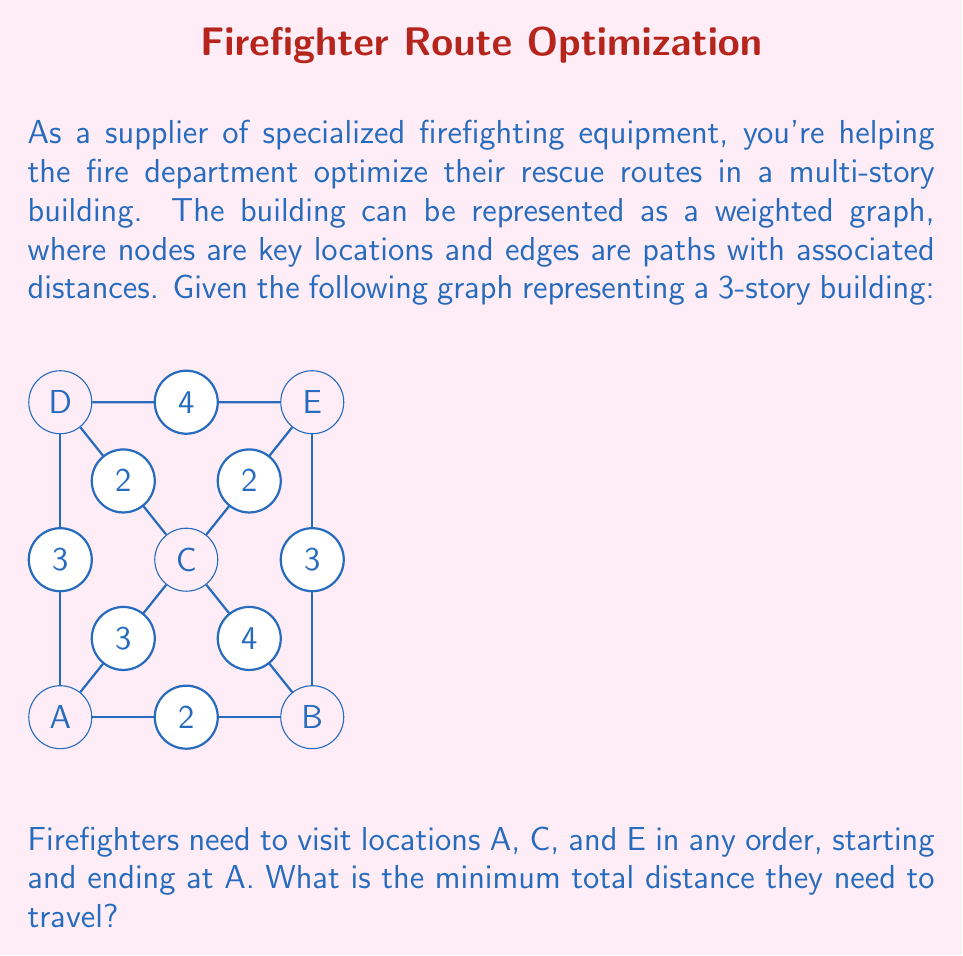Help me with this question. To solve this problem, we need to find the shortest path that starts at A, visits C and E in any order, and returns to A. This is a variation of the Traveling Salesman Problem.

Given the small number of nodes, we can solve this by considering all possible routes:

1. A → C → E → A
   Distance: 3 + 2 + 3 = 8

2. A → E → C → A
   Distance: 5 + 2 + 3 = 10

Let's calculate these distances step-by-step:

Route 1: A → C → E → A
- A to C: 3
- C to E: 2
- E to A: 3 (E → B → A)
Total: 3 + 2 + 3 = 8

Route 2: A → E → C → A
- A to E: 5 (A → B → E)
- E to C: 2
- C to A: 3
Total: 5 + 2 + 3 = 10

The shorter of these two routes is Route 1, with a total distance of 8.

We can verify that this is indeed the shortest path by considering that:
1. The direct path from A to E (through B) is 5, which is longer than going through C (3 + 2 = 5).
2. There's no shorter way to return from E to A than through B (distance 3).

Therefore, the minimum total distance is 8.
Answer: 8 